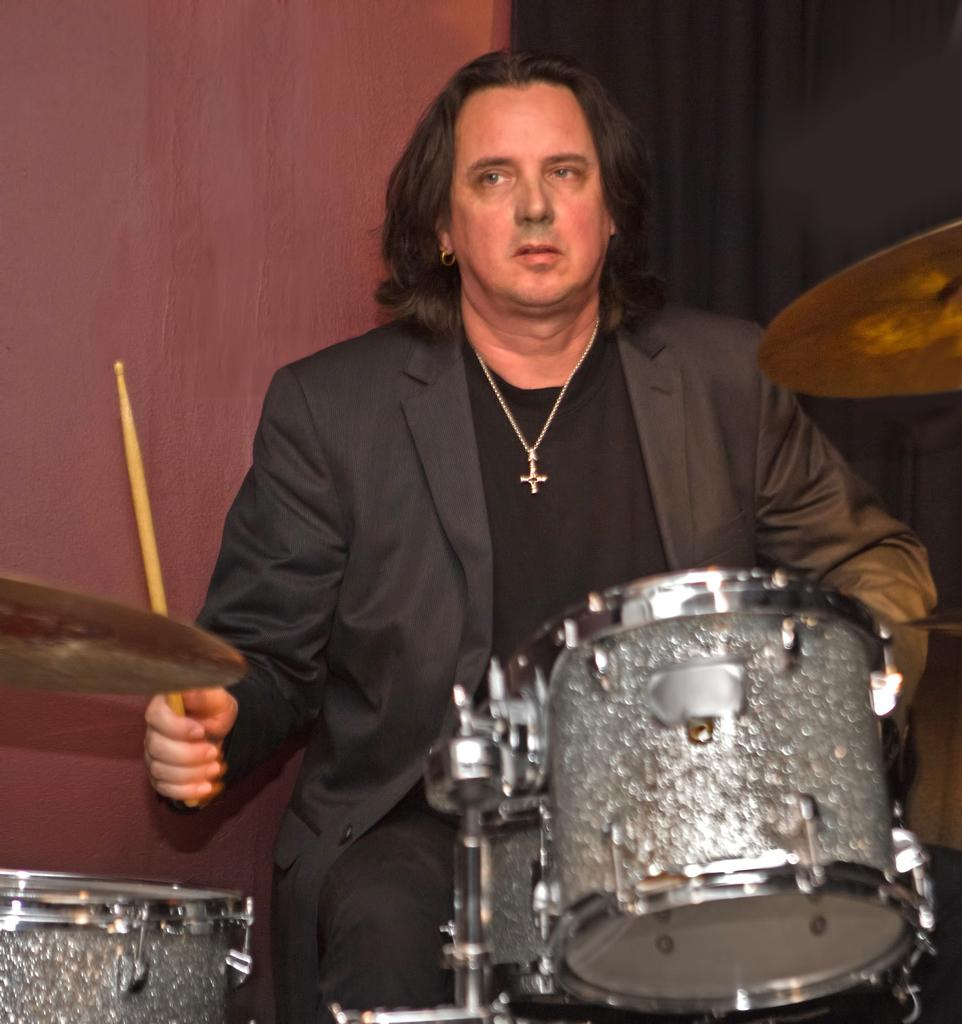What is the man in the image doing? The man is sitting in the image. What is the man holding in his hand? The man is holding a stick in his hand. What objects are in front of the man? There are drums in front of the man. What is visible behind the man? There is a black curtain behind the man, and a wall behind the curtain. What type of cup is the man holding in the image? The man is not holding a cup in the image; he is holding a stick. 